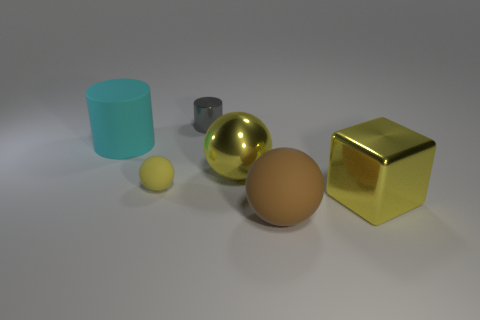Add 3 large rubber cylinders. How many objects exist? 9 Subtract all cylinders. How many objects are left? 4 Add 1 cyan things. How many cyan things are left? 2 Add 6 yellow metallic balls. How many yellow metallic balls exist? 7 Subtract 0 blue cubes. How many objects are left? 6 Subtract all tiny green shiny balls. Subtract all big matte things. How many objects are left? 4 